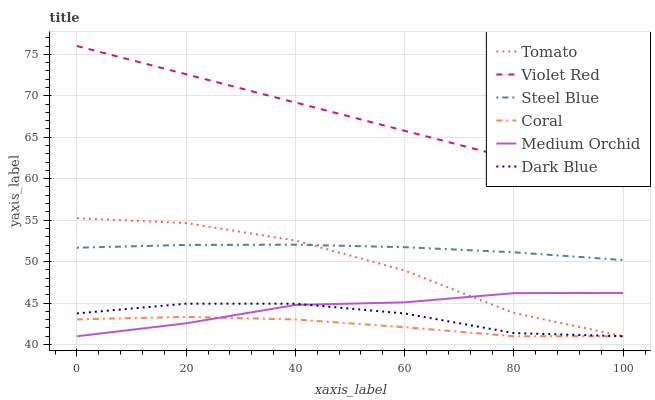Does Coral have the minimum area under the curve?
Answer yes or no. Yes. Does Violet Red have the maximum area under the curve?
Answer yes or no. Yes. Does Violet Red have the minimum area under the curve?
Answer yes or no. No. Does Coral have the maximum area under the curve?
Answer yes or no. No. Is Violet Red the smoothest?
Answer yes or no. Yes. Is Tomato the roughest?
Answer yes or no. Yes. Is Coral the smoothest?
Answer yes or no. No. Is Coral the roughest?
Answer yes or no. No. Does Tomato have the lowest value?
Answer yes or no. Yes. Does Violet Red have the lowest value?
Answer yes or no. No. Does Violet Red have the highest value?
Answer yes or no. Yes. Does Coral have the highest value?
Answer yes or no. No. Is Steel Blue less than Violet Red?
Answer yes or no. Yes. Is Steel Blue greater than Coral?
Answer yes or no. Yes. Does Medium Orchid intersect Tomato?
Answer yes or no. Yes. Is Medium Orchid less than Tomato?
Answer yes or no. No. Is Medium Orchid greater than Tomato?
Answer yes or no. No. Does Steel Blue intersect Violet Red?
Answer yes or no. No. 